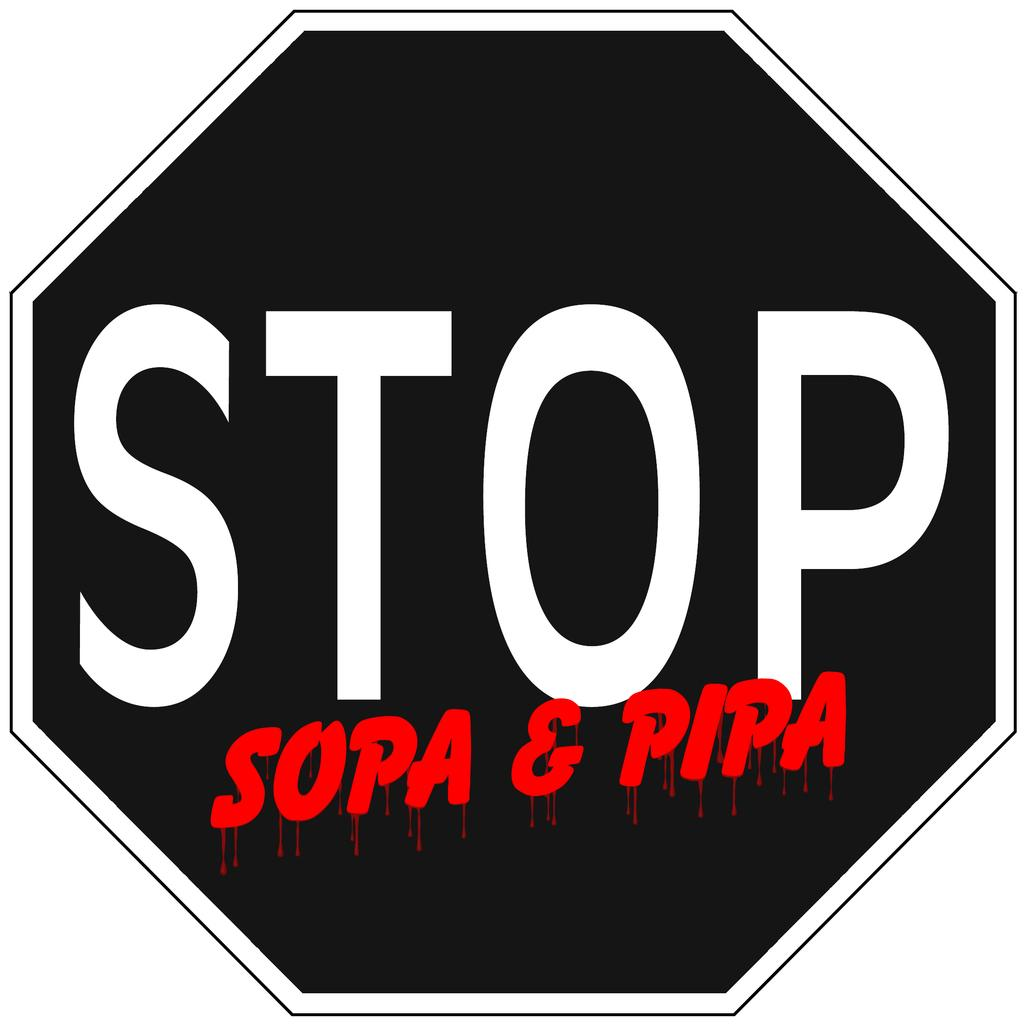<image>
Relay a brief, clear account of the picture shown. A black sign that says Stop in white and underneath Sopa & Pipa in red. 